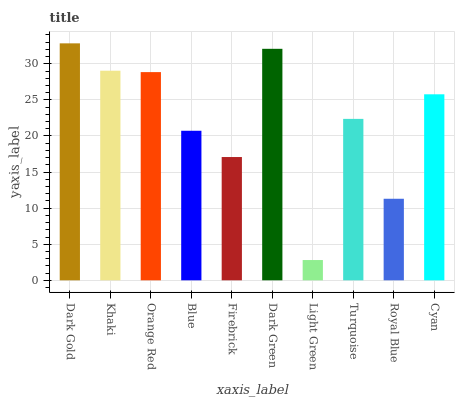Is Light Green the minimum?
Answer yes or no. Yes. Is Dark Gold the maximum?
Answer yes or no. Yes. Is Khaki the minimum?
Answer yes or no. No. Is Khaki the maximum?
Answer yes or no. No. Is Dark Gold greater than Khaki?
Answer yes or no. Yes. Is Khaki less than Dark Gold?
Answer yes or no. Yes. Is Khaki greater than Dark Gold?
Answer yes or no. No. Is Dark Gold less than Khaki?
Answer yes or no. No. Is Cyan the high median?
Answer yes or no. Yes. Is Turquoise the low median?
Answer yes or no. Yes. Is Turquoise the high median?
Answer yes or no. No. Is Cyan the low median?
Answer yes or no. No. 